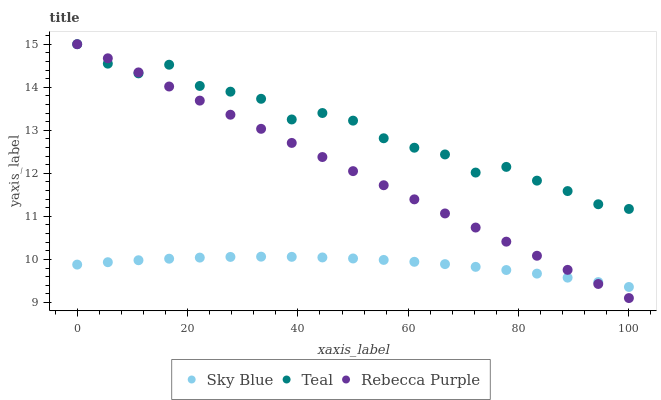Does Sky Blue have the minimum area under the curve?
Answer yes or no. Yes. Does Teal have the maximum area under the curve?
Answer yes or no. Yes. Does Rebecca Purple have the minimum area under the curve?
Answer yes or no. No. Does Rebecca Purple have the maximum area under the curve?
Answer yes or no. No. Is Rebecca Purple the smoothest?
Answer yes or no. Yes. Is Teal the roughest?
Answer yes or no. Yes. Is Teal the smoothest?
Answer yes or no. No. Is Rebecca Purple the roughest?
Answer yes or no. No. Does Rebecca Purple have the lowest value?
Answer yes or no. Yes. Does Teal have the lowest value?
Answer yes or no. No. Does Teal have the highest value?
Answer yes or no. Yes. Is Sky Blue less than Teal?
Answer yes or no. Yes. Is Teal greater than Sky Blue?
Answer yes or no. Yes. Does Rebecca Purple intersect Sky Blue?
Answer yes or no. Yes. Is Rebecca Purple less than Sky Blue?
Answer yes or no. No. Is Rebecca Purple greater than Sky Blue?
Answer yes or no. No. Does Sky Blue intersect Teal?
Answer yes or no. No. 